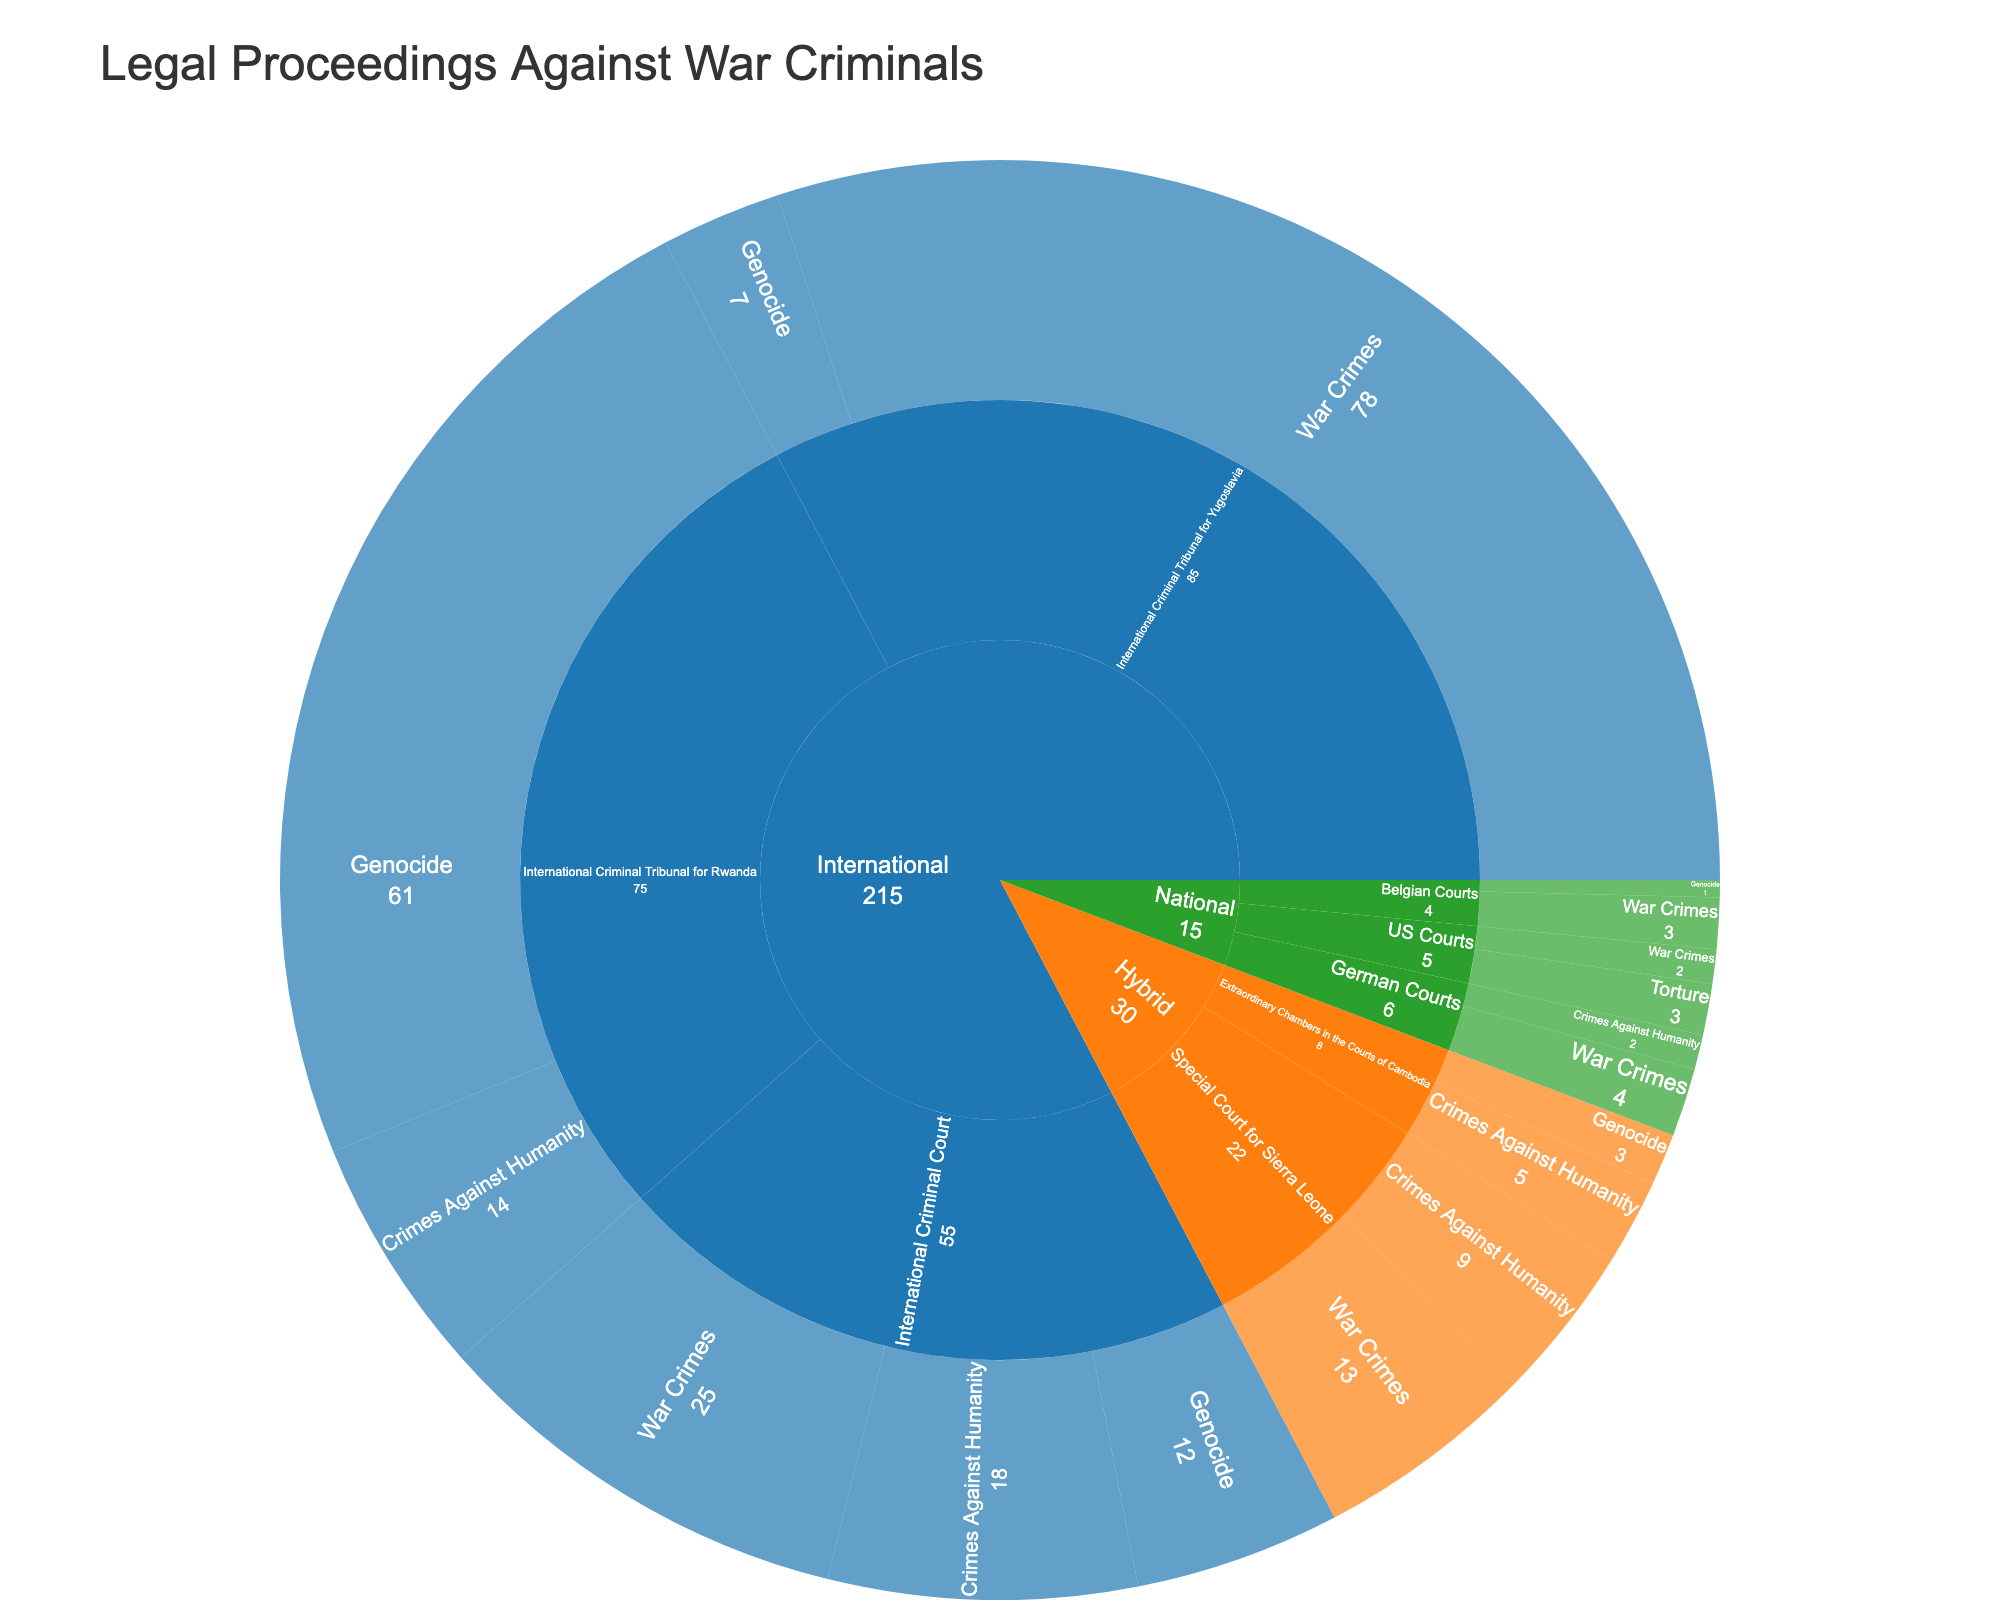Which crime category has the highest number of cases? By observing the outer ring of the sunburst plot, find the segment with the largest value. "War Crimes" has multiple segments across different courts, and adding them yields the highest total.
Answer: War Crimes How many cases of Genocide are handled by the International Criminal Tribunal for Rwanda? Locate the "International" jurisdiction in the sunburst plot, then the "International Criminal Tribunal for Rwanda" court, and finally the "Genocide" segment; the value is shown as 61.
Answer: 61 Which jurisdiction has the most cases overall? Sum the values of cases for each jurisdiction (International, Hybrid, National). The "International" jurisdiction has the highest total sum.
Answer: International Are there more cases of War Crimes or Crimes Against Humanity? Sum the cases for "War Crimes" segments and the cases for "Crimes Against Humanity" segments. There are more "War Crimes" cases.
Answer: War Crimes Which court under the Hybrid jurisdiction handles the most cases? Within the "Hybrid" jurisdiction, compare the total number of cases for each court (Special Court for Sierra Leone and Extraordinary Chambers in the Courts of Cambodia). The Special Court for Sierra Leone handles more cases.
Answer: Special Court for Sierra Leone How many cases does the International Criminal Court handle in total? Locate the "International Criminal Court" within the "International" jurisdiction and sum its segments' values (Genocide, Crimes Against Humanity, and War Crimes). The total is 12 + 18 + 25.
Answer: 55 Which court handles the fewest cases in the sunburst plot? Compare the total number of cases for each court. The Belgian Courts handle the fewest cases.
Answer: Belgian Courts What is the total number of cases across all national jurisdictions? Sum the number of cases across all national jurisdictions (German Courts, US Courts, Belgian Courts). The total is 4 + 2 + 3 + 2 + 1 + 3.
Answer: 15 How many more cases of War Crimes than Genocide are there in the International Criminal Tribunal for Yugoslavia? Find the values for "War Crimes" and "Genocide" within the International Criminal Tribunal for Yugoslavia and calculate the difference (78 - 7).
Answer: 71 